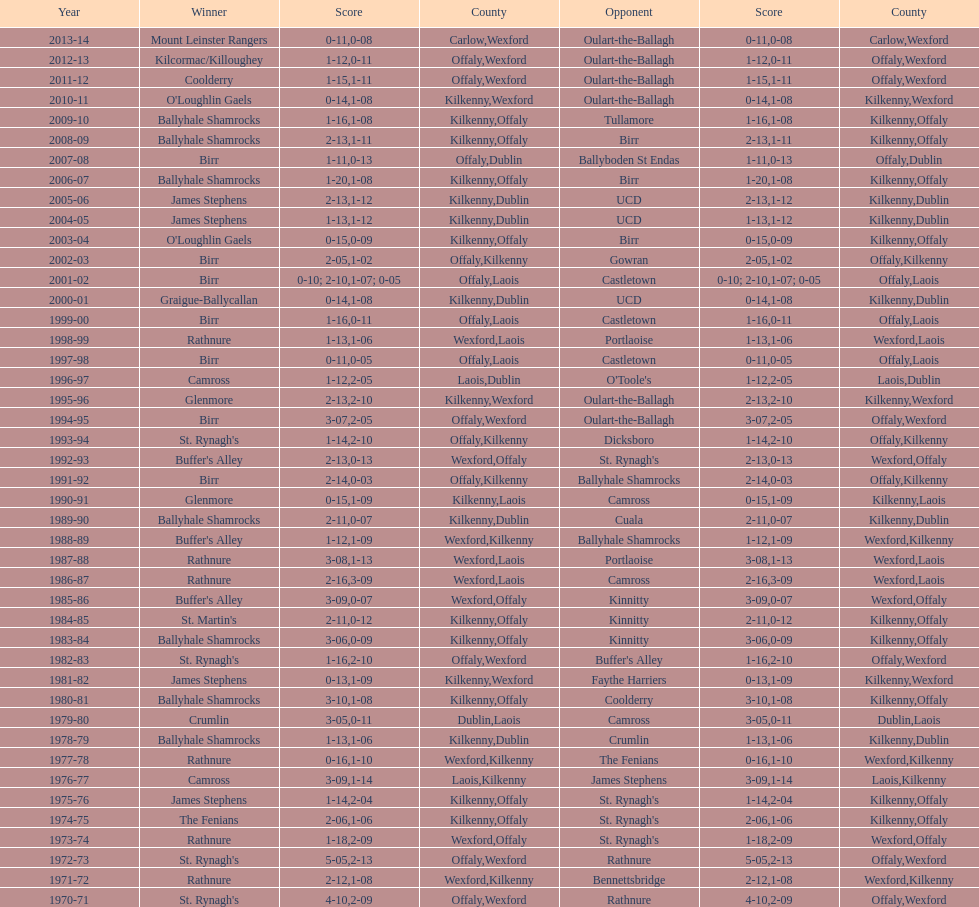Which country secured the greatest number of wins? Kilkenny. 